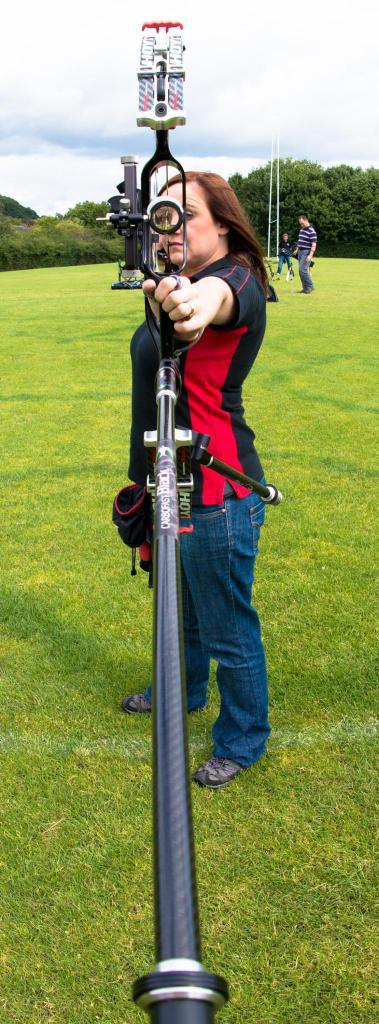Who is the main subject in the image? There is a woman in the center of the image. What is the woman doing in the image? The woman is standing on the ground and holding a bow and arrow. Can you describe the background of the image? There is a person, trees, and the sky visible in the background of the image. What is the condition of the sky in the image? The sky is visible in the background of the image, and clouds are present. What type of art can be seen hanging from the trees in the image? There is no art hanging from the trees in the image; it features a woman holding a bow and arrow, with a person, trees, and the sky visible in the background. Can you tell me how many pails are present in the image? There are no pails present in the image. 